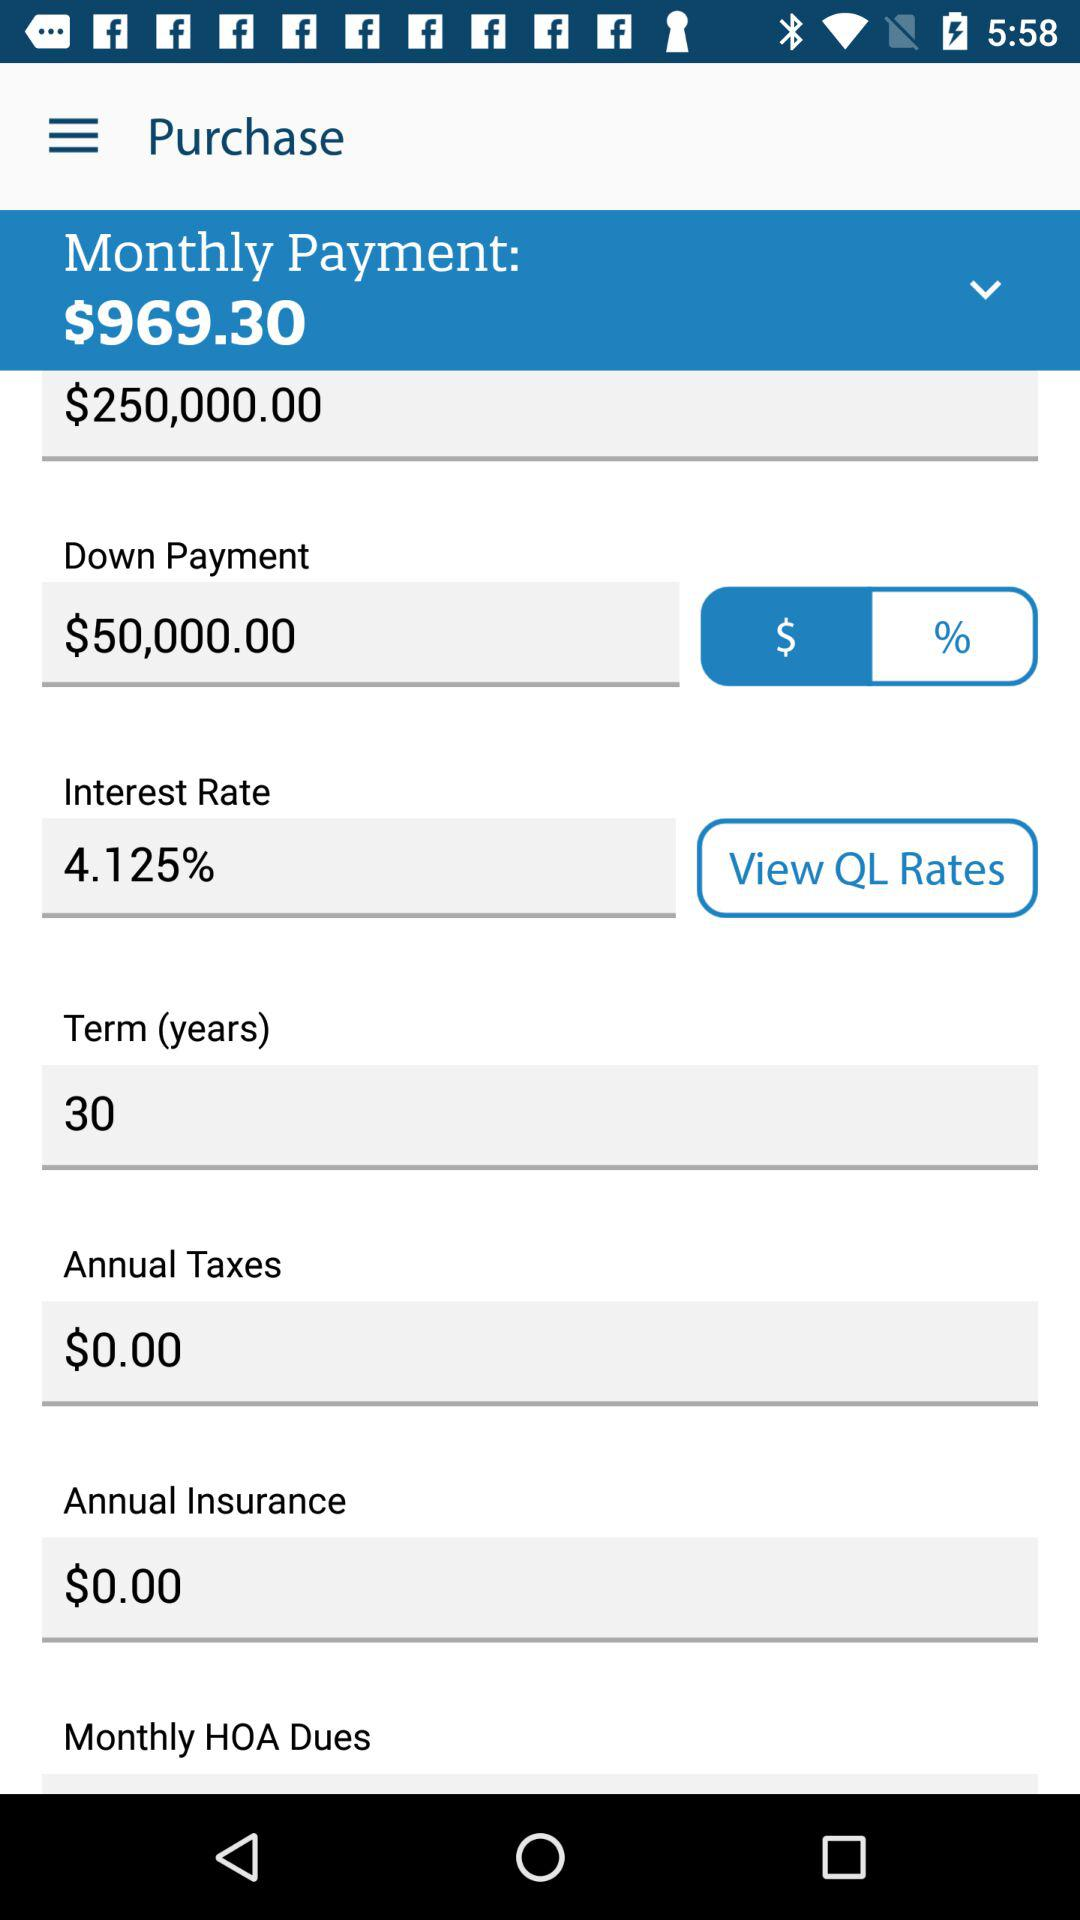What is the interest rate? The interest rate is 4.125%. 